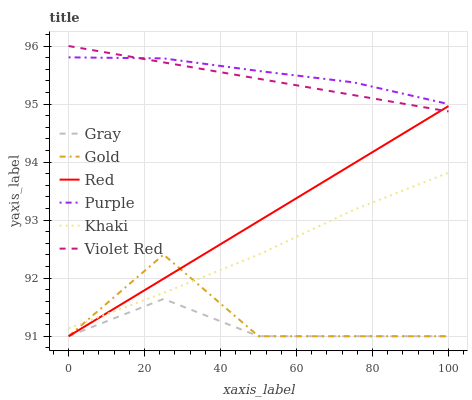Does Violet Red have the minimum area under the curve?
Answer yes or no. No. Does Violet Red have the maximum area under the curve?
Answer yes or no. No. Is Violet Red the smoothest?
Answer yes or no. No. Is Violet Red the roughest?
Answer yes or no. No. Does Violet Red have the lowest value?
Answer yes or no. No. Does Khaki have the highest value?
Answer yes or no. No. Is Gold less than Violet Red?
Answer yes or no. Yes. Is Purple greater than Gray?
Answer yes or no. Yes. Does Gold intersect Violet Red?
Answer yes or no. No. 